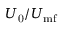<formula> <loc_0><loc_0><loc_500><loc_500>U _ { 0 } / U _ { m f }</formula> 